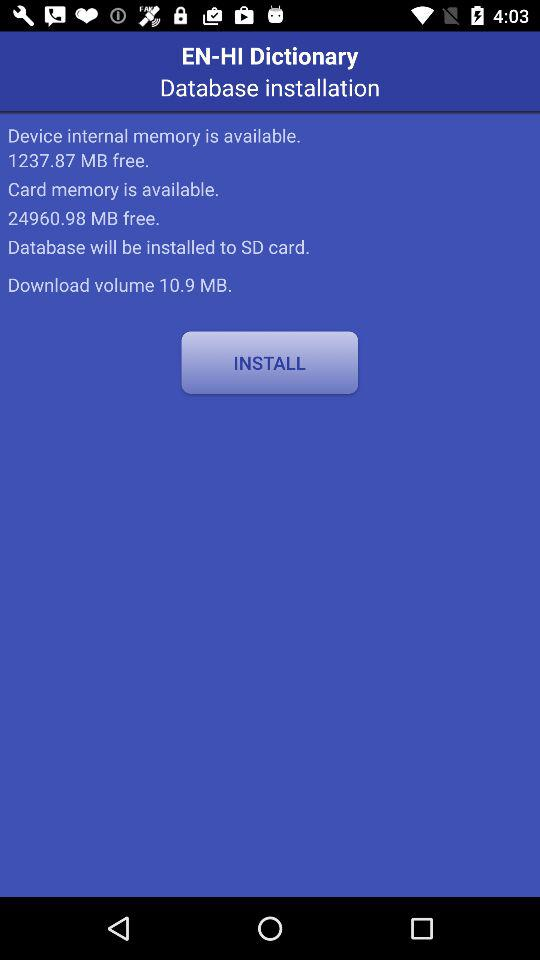What is the size of the download volume? The size of the download volume is 10.9 MB. 